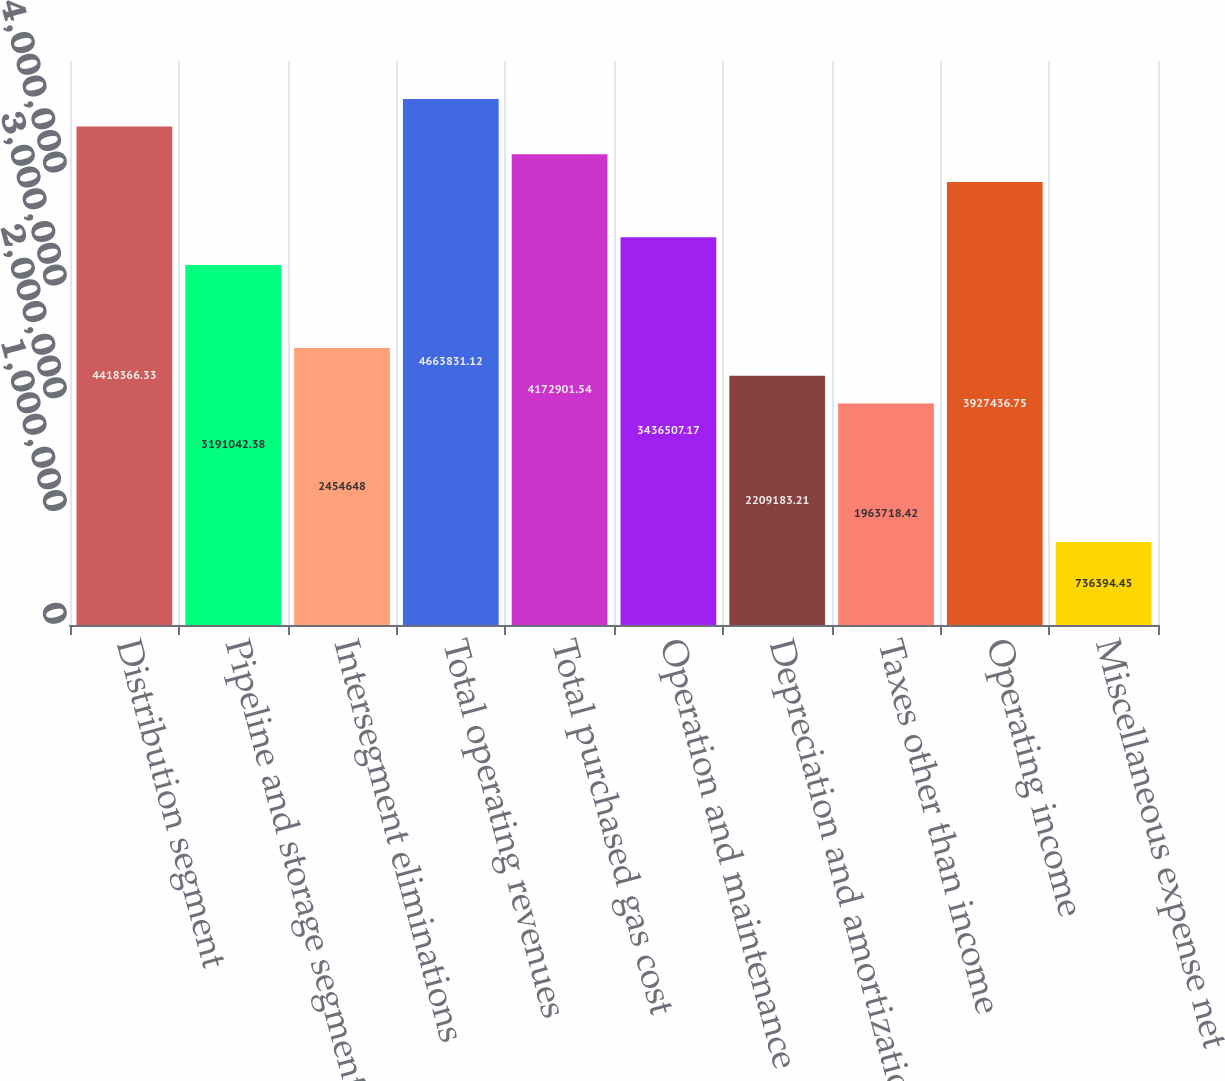Convert chart to OTSL. <chart><loc_0><loc_0><loc_500><loc_500><bar_chart><fcel>Distribution segment<fcel>Pipeline and storage segment<fcel>Intersegment eliminations<fcel>Total operating revenues<fcel>Total purchased gas cost<fcel>Operation and maintenance<fcel>Depreciation and amortization<fcel>Taxes other than income<fcel>Operating income<fcel>Miscellaneous expense net<nl><fcel>4.41837e+06<fcel>3.19104e+06<fcel>2.45465e+06<fcel>4.66383e+06<fcel>4.1729e+06<fcel>3.43651e+06<fcel>2.20918e+06<fcel>1.96372e+06<fcel>3.92744e+06<fcel>736394<nl></chart> 